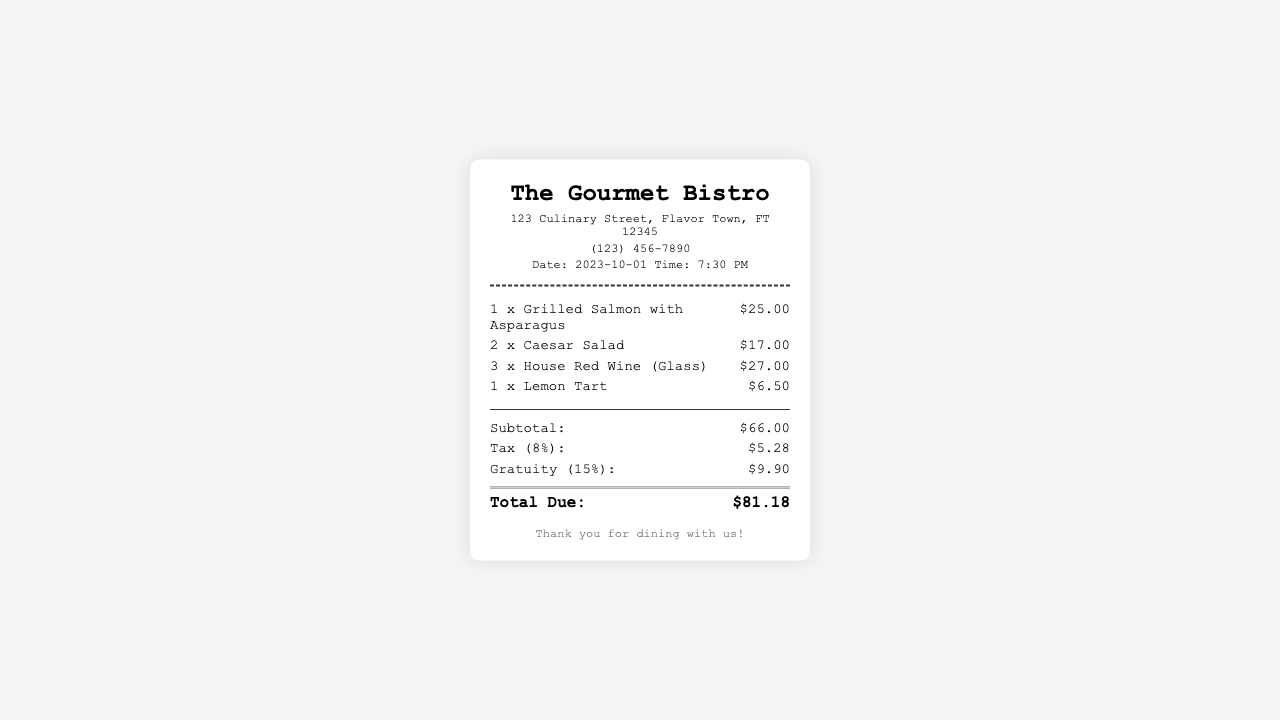what is the restaurant name? The name of the restaurant is prominently displayed at the top of the receipt.
Answer: The Gourmet Bistro what is the date of the receipt? The date can be found in the header section, listing when the transaction occurred.
Answer: 2023-10-01 how many Caesar Salads were ordered? The number of Caesar Salads is indicated in the itemized section of the receipt.
Answer: 2 what is the total amount of tax charged? The total amount of tax is listed under the tax line in the totals section.
Answer: $5.28 what is the subtotal before tax and gratuity? The subtotal is the sum of all itemized expenses before tax and gratuity, as shown in the totals section.
Answer: $66.00 how much was the gratuity? The gratuity amount is specifically stated in the totals section of the receipt.
Answer: $9.90 what time was the dining experience? The time of the meal is provided in the header alongside the date.
Answer: 7:30 PM what is the total due for the meal? The total due is the final amount that needs to be paid, summarized at the bottom of the totals section.
Answer: $81.18 what type of wine was ordered? The type of wine is described in the itemized list under the beverages.
Answer: House Red Wine (Glass) 